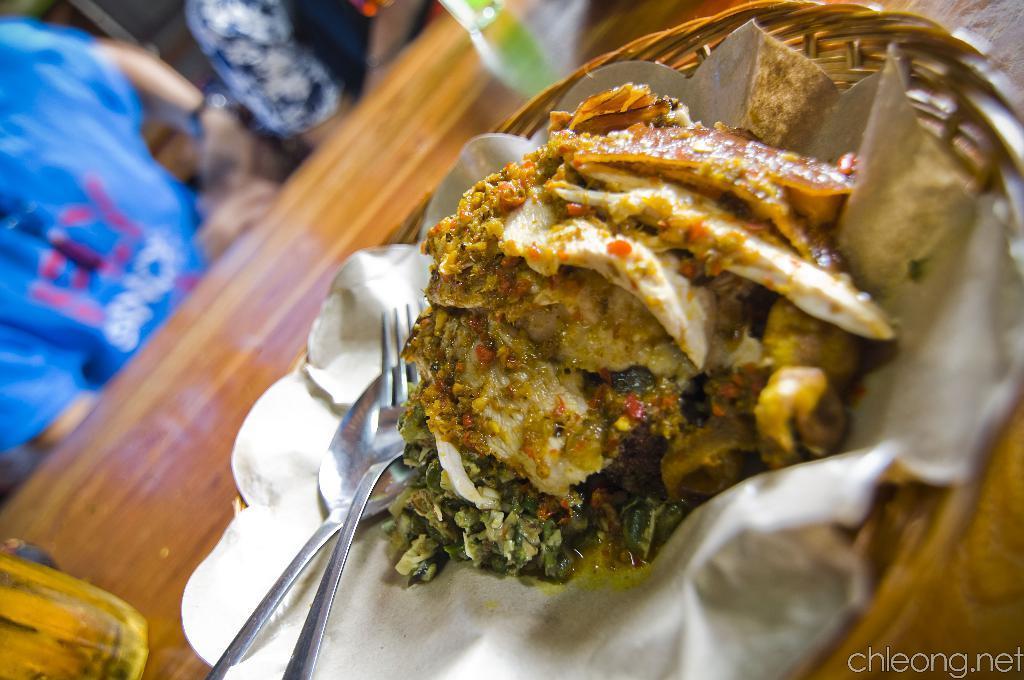In one or two sentences, can you explain what this image depicts? In the image there is some cooked food item served in a bowl made up of wooden objects and the background of the food item is blur, there is a fork and a spoon beside the food item. 